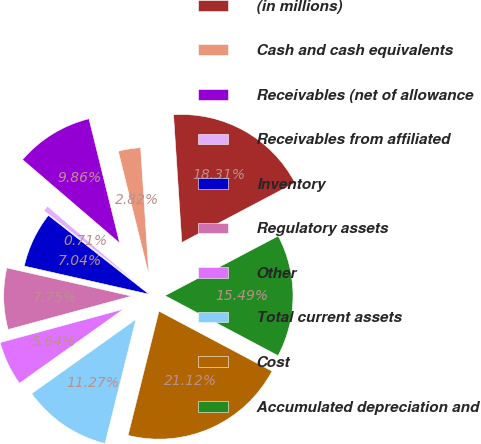Convert chart. <chart><loc_0><loc_0><loc_500><loc_500><pie_chart><fcel>(in millions)<fcel>Cash and cash equivalents<fcel>Receivables (net of allowance<fcel>Receivables from affiliated<fcel>Inventory<fcel>Regulatory assets<fcel>Other<fcel>Total current assets<fcel>Cost<fcel>Accumulated depreciation and<nl><fcel>18.31%<fcel>2.82%<fcel>9.86%<fcel>0.71%<fcel>7.04%<fcel>7.75%<fcel>5.64%<fcel>11.27%<fcel>21.12%<fcel>15.49%<nl></chart> 